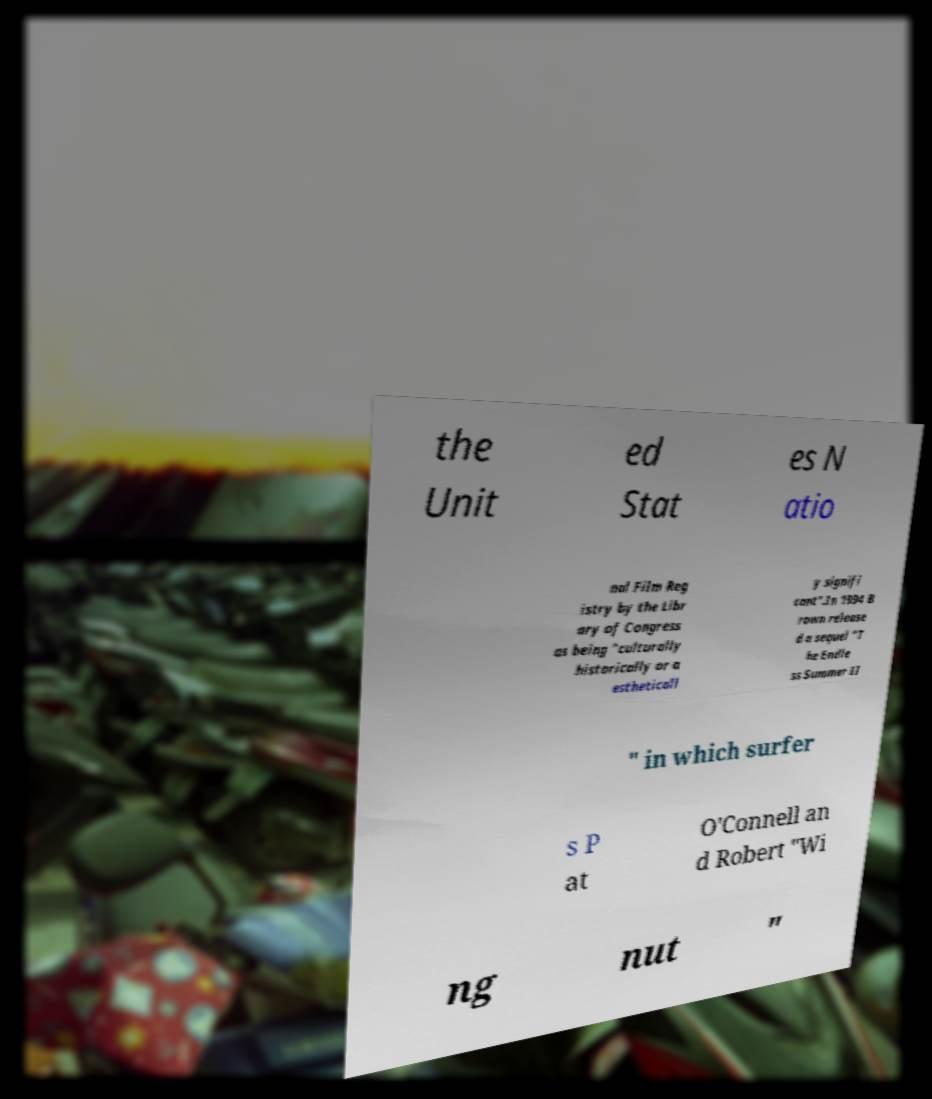What messages or text are displayed in this image? I need them in a readable, typed format. the Unit ed Stat es N atio nal Film Reg istry by the Libr ary of Congress as being "culturally historically or a estheticall y signifi cant".In 1994 B rown release d a sequel "T he Endle ss Summer II " in which surfer s P at O'Connell an d Robert "Wi ng nut " 